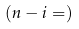<formula> <loc_0><loc_0><loc_500><loc_500>( n - i = )</formula> 